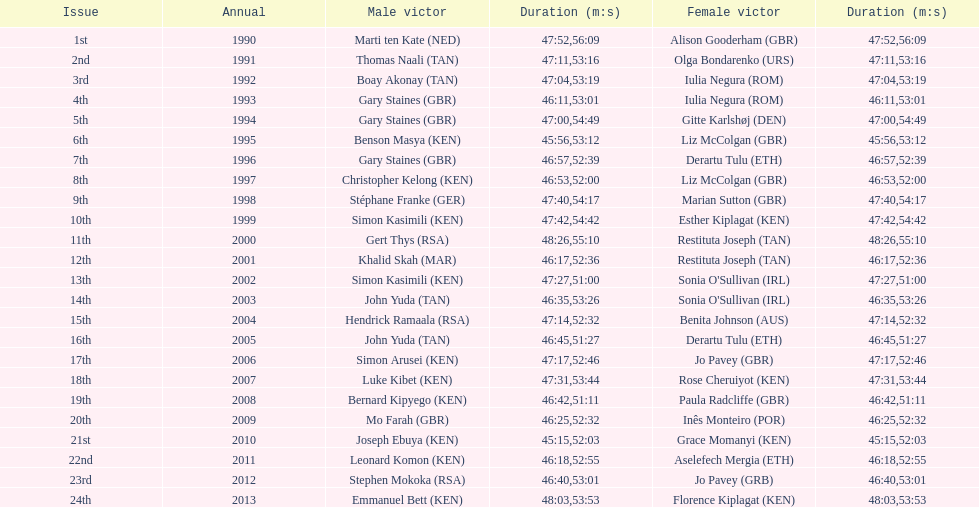What is the name of the first women's winner? Alison Gooderham. 